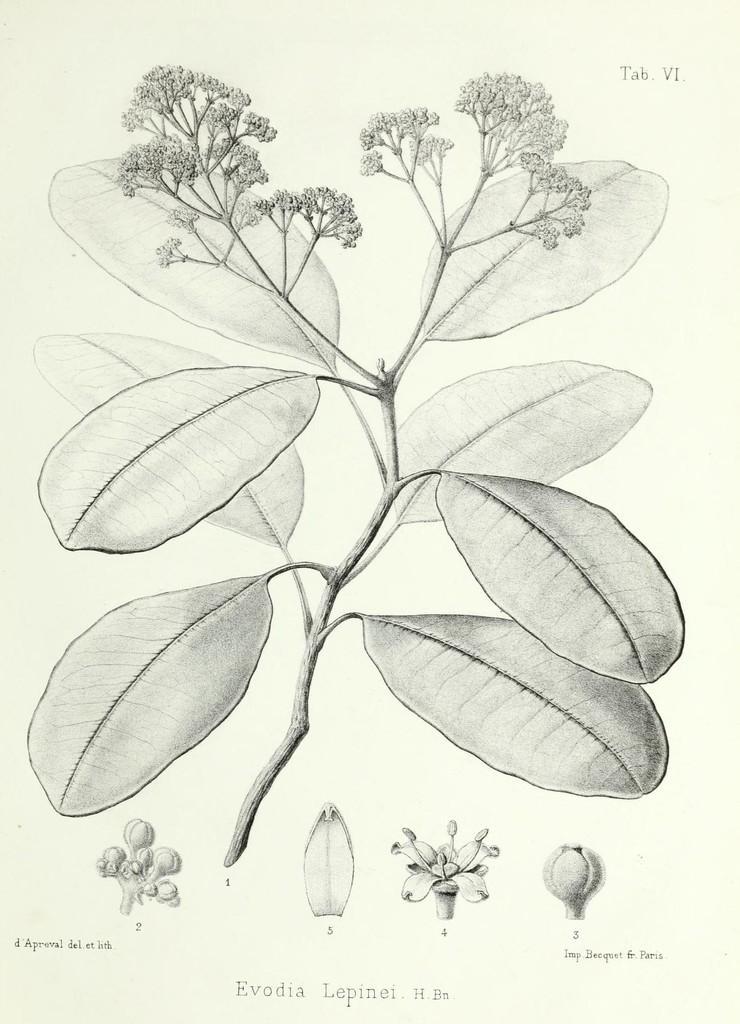Please provide a concise description of this image. In this picture I can see there is a plant and there are some leaves and buds and this is a drawing. 